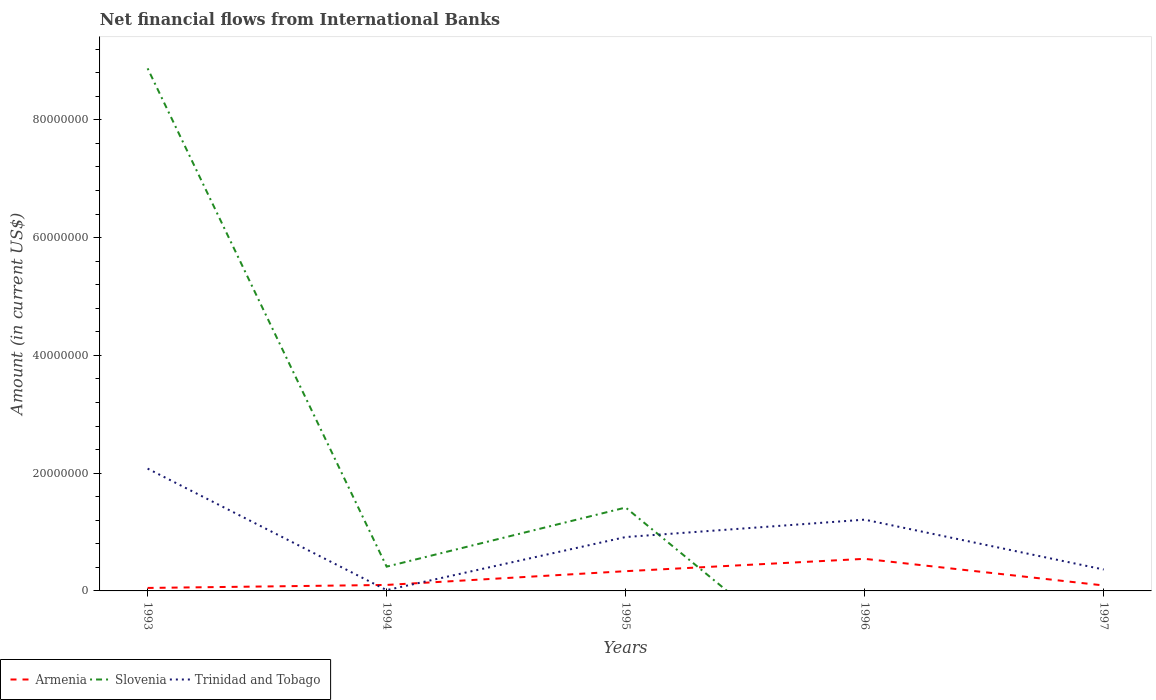Does the line corresponding to Armenia intersect with the line corresponding to Trinidad and Tobago?
Offer a very short reply. Yes. Across all years, what is the maximum net financial aid flows in Armenia?
Keep it short and to the point. 5.06e+05. What is the total net financial aid flows in Armenia in the graph?
Ensure brevity in your answer.  -5.11e+05. What is the difference between the highest and the second highest net financial aid flows in Slovenia?
Give a very brief answer. 8.87e+07. What is the difference between the highest and the lowest net financial aid flows in Slovenia?
Ensure brevity in your answer.  1. Is the net financial aid flows in Armenia strictly greater than the net financial aid flows in Trinidad and Tobago over the years?
Offer a terse response. No. How many lines are there?
Provide a short and direct response. 3. Are the values on the major ticks of Y-axis written in scientific E-notation?
Your answer should be compact. No. Does the graph contain any zero values?
Give a very brief answer. Yes. Where does the legend appear in the graph?
Offer a very short reply. Bottom left. How are the legend labels stacked?
Provide a short and direct response. Horizontal. What is the title of the graph?
Make the answer very short. Net financial flows from International Banks. Does "Comoros" appear as one of the legend labels in the graph?
Your response must be concise. No. What is the label or title of the Y-axis?
Ensure brevity in your answer.  Amount (in current US$). What is the Amount (in current US$) in Armenia in 1993?
Your answer should be very brief. 5.06e+05. What is the Amount (in current US$) in Slovenia in 1993?
Your answer should be compact. 8.87e+07. What is the Amount (in current US$) in Trinidad and Tobago in 1993?
Keep it short and to the point. 2.08e+07. What is the Amount (in current US$) in Armenia in 1994?
Make the answer very short. 1.02e+06. What is the Amount (in current US$) in Slovenia in 1994?
Your answer should be very brief. 4.12e+06. What is the Amount (in current US$) of Trinidad and Tobago in 1994?
Offer a terse response. 1.35e+05. What is the Amount (in current US$) of Armenia in 1995?
Provide a succinct answer. 3.35e+06. What is the Amount (in current US$) in Slovenia in 1995?
Offer a terse response. 1.42e+07. What is the Amount (in current US$) in Trinidad and Tobago in 1995?
Offer a terse response. 9.15e+06. What is the Amount (in current US$) in Armenia in 1996?
Ensure brevity in your answer.  5.45e+06. What is the Amount (in current US$) of Trinidad and Tobago in 1996?
Keep it short and to the point. 1.21e+07. What is the Amount (in current US$) of Armenia in 1997?
Provide a succinct answer. 9.28e+05. What is the Amount (in current US$) of Trinidad and Tobago in 1997?
Your answer should be compact. 3.64e+06. Across all years, what is the maximum Amount (in current US$) of Armenia?
Offer a terse response. 5.45e+06. Across all years, what is the maximum Amount (in current US$) of Slovenia?
Keep it short and to the point. 8.87e+07. Across all years, what is the maximum Amount (in current US$) of Trinidad and Tobago?
Offer a terse response. 2.08e+07. Across all years, what is the minimum Amount (in current US$) in Armenia?
Provide a succinct answer. 5.06e+05. Across all years, what is the minimum Amount (in current US$) in Trinidad and Tobago?
Offer a terse response. 1.35e+05. What is the total Amount (in current US$) of Armenia in the graph?
Your response must be concise. 1.12e+07. What is the total Amount (in current US$) of Slovenia in the graph?
Provide a short and direct response. 1.07e+08. What is the total Amount (in current US$) in Trinidad and Tobago in the graph?
Provide a succinct answer. 4.58e+07. What is the difference between the Amount (in current US$) of Armenia in 1993 and that in 1994?
Your answer should be very brief. -5.11e+05. What is the difference between the Amount (in current US$) of Slovenia in 1993 and that in 1994?
Make the answer very short. 8.46e+07. What is the difference between the Amount (in current US$) of Trinidad and Tobago in 1993 and that in 1994?
Offer a very short reply. 2.06e+07. What is the difference between the Amount (in current US$) in Armenia in 1993 and that in 1995?
Your response must be concise. -2.84e+06. What is the difference between the Amount (in current US$) of Slovenia in 1993 and that in 1995?
Make the answer very short. 7.46e+07. What is the difference between the Amount (in current US$) of Trinidad and Tobago in 1993 and that in 1995?
Offer a terse response. 1.16e+07. What is the difference between the Amount (in current US$) of Armenia in 1993 and that in 1996?
Offer a very short reply. -4.94e+06. What is the difference between the Amount (in current US$) of Trinidad and Tobago in 1993 and that in 1996?
Offer a very short reply. 8.67e+06. What is the difference between the Amount (in current US$) of Armenia in 1993 and that in 1997?
Keep it short and to the point. -4.22e+05. What is the difference between the Amount (in current US$) of Trinidad and Tobago in 1993 and that in 1997?
Your answer should be compact. 1.71e+07. What is the difference between the Amount (in current US$) in Armenia in 1994 and that in 1995?
Provide a succinct answer. -2.33e+06. What is the difference between the Amount (in current US$) of Slovenia in 1994 and that in 1995?
Offer a terse response. -1.00e+07. What is the difference between the Amount (in current US$) of Trinidad and Tobago in 1994 and that in 1995?
Give a very brief answer. -9.02e+06. What is the difference between the Amount (in current US$) of Armenia in 1994 and that in 1996?
Provide a succinct answer. -4.43e+06. What is the difference between the Amount (in current US$) of Trinidad and Tobago in 1994 and that in 1996?
Your answer should be very brief. -1.20e+07. What is the difference between the Amount (in current US$) of Armenia in 1994 and that in 1997?
Ensure brevity in your answer.  8.90e+04. What is the difference between the Amount (in current US$) of Trinidad and Tobago in 1994 and that in 1997?
Make the answer very short. -3.50e+06. What is the difference between the Amount (in current US$) in Armenia in 1995 and that in 1996?
Your response must be concise. -2.10e+06. What is the difference between the Amount (in current US$) in Trinidad and Tobago in 1995 and that in 1996?
Keep it short and to the point. -2.95e+06. What is the difference between the Amount (in current US$) of Armenia in 1995 and that in 1997?
Your response must be concise. 2.42e+06. What is the difference between the Amount (in current US$) in Trinidad and Tobago in 1995 and that in 1997?
Your answer should be compact. 5.51e+06. What is the difference between the Amount (in current US$) in Armenia in 1996 and that in 1997?
Your response must be concise. 4.52e+06. What is the difference between the Amount (in current US$) of Trinidad and Tobago in 1996 and that in 1997?
Keep it short and to the point. 8.46e+06. What is the difference between the Amount (in current US$) of Armenia in 1993 and the Amount (in current US$) of Slovenia in 1994?
Offer a very short reply. -3.62e+06. What is the difference between the Amount (in current US$) in Armenia in 1993 and the Amount (in current US$) in Trinidad and Tobago in 1994?
Ensure brevity in your answer.  3.71e+05. What is the difference between the Amount (in current US$) in Slovenia in 1993 and the Amount (in current US$) in Trinidad and Tobago in 1994?
Your answer should be compact. 8.86e+07. What is the difference between the Amount (in current US$) of Armenia in 1993 and the Amount (in current US$) of Slovenia in 1995?
Give a very brief answer. -1.37e+07. What is the difference between the Amount (in current US$) in Armenia in 1993 and the Amount (in current US$) in Trinidad and Tobago in 1995?
Your answer should be very brief. -8.64e+06. What is the difference between the Amount (in current US$) of Slovenia in 1993 and the Amount (in current US$) of Trinidad and Tobago in 1995?
Ensure brevity in your answer.  7.96e+07. What is the difference between the Amount (in current US$) of Armenia in 1993 and the Amount (in current US$) of Trinidad and Tobago in 1996?
Your answer should be very brief. -1.16e+07. What is the difference between the Amount (in current US$) of Slovenia in 1993 and the Amount (in current US$) of Trinidad and Tobago in 1996?
Make the answer very short. 7.66e+07. What is the difference between the Amount (in current US$) in Armenia in 1993 and the Amount (in current US$) in Trinidad and Tobago in 1997?
Your answer should be very brief. -3.13e+06. What is the difference between the Amount (in current US$) in Slovenia in 1993 and the Amount (in current US$) in Trinidad and Tobago in 1997?
Provide a succinct answer. 8.51e+07. What is the difference between the Amount (in current US$) of Armenia in 1994 and the Amount (in current US$) of Slovenia in 1995?
Your answer should be very brief. -1.31e+07. What is the difference between the Amount (in current US$) of Armenia in 1994 and the Amount (in current US$) of Trinidad and Tobago in 1995?
Provide a succinct answer. -8.13e+06. What is the difference between the Amount (in current US$) in Slovenia in 1994 and the Amount (in current US$) in Trinidad and Tobago in 1995?
Make the answer very short. -5.03e+06. What is the difference between the Amount (in current US$) of Armenia in 1994 and the Amount (in current US$) of Trinidad and Tobago in 1996?
Your response must be concise. -1.11e+07. What is the difference between the Amount (in current US$) in Slovenia in 1994 and the Amount (in current US$) in Trinidad and Tobago in 1996?
Your response must be concise. -7.98e+06. What is the difference between the Amount (in current US$) of Armenia in 1994 and the Amount (in current US$) of Trinidad and Tobago in 1997?
Provide a short and direct response. -2.62e+06. What is the difference between the Amount (in current US$) in Slovenia in 1994 and the Amount (in current US$) in Trinidad and Tobago in 1997?
Your answer should be very brief. 4.87e+05. What is the difference between the Amount (in current US$) of Armenia in 1995 and the Amount (in current US$) of Trinidad and Tobago in 1996?
Give a very brief answer. -8.75e+06. What is the difference between the Amount (in current US$) of Slovenia in 1995 and the Amount (in current US$) of Trinidad and Tobago in 1996?
Provide a short and direct response. 2.06e+06. What is the difference between the Amount (in current US$) of Armenia in 1995 and the Amount (in current US$) of Trinidad and Tobago in 1997?
Offer a very short reply. -2.86e+05. What is the difference between the Amount (in current US$) of Slovenia in 1995 and the Amount (in current US$) of Trinidad and Tobago in 1997?
Make the answer very short. 1.05e+07. What is the difference between the Amount (in current US$) of Armenia in 1996 and the Amount (in current US$) of Trinidad and Tobago in 1997?
Give a very brief answer. 1.81e+06. What is the average Amount (in current US$) in Armenia per year?
Ensure brevity in your answer.  2.25e+06. What is the average Amount (in current US$) in Slovenia per year?
Offer a terse response. 2.14e+07. What is the average Amount (in current US$) in Trinidad and Tobago per year?
Ensure brevity in your answer.  9.16e+06. In the year 1993, what is the difference between the Amount (in current US$) of Armenia and Amount (in current US$) of Slovenia?
Provide a short and direct response. -8.82e+07. In the year 1993, what is the difference between the Amount (in current US$) of Armenia and Amount (in current US$) of Trinidad and Tobago?
Provide a short and direct response. -2.03e+07. In the year 1993, what is the difference between the Amount (in current US$) in Slovenia and Amount (in current US$) in Trinidad and Tobago?
Your response must be concise. 6.80e+07. In the year 1994, what is the difference between the Amount (in current US$) in Armenia and Amount (in current US$) in Slovenia?
Your answer should be compact. -3.11e+06. In the year 1994, what is the difference between the Amount (in current US$) of Armenia and Amount (in current US$) of Trinidad and Tobago?
Your answer should be very brief. 8.82e+05. In the year 1994, what is the difference between the Amount (in current US$) of Slovenia and Amount (in current US$) of Trinidad and Tobago?
Ensure brevity in your answer.  3.99e+06. In the year 1995, what is the difference between the Amount (in current US$) in Armenia and Amount (in current US$) in Slovenia?
Provide a short and direct response. -1.08e+07. In the year 1995, what is the difference between the Amount (in current US$) in Armenia and Amount (in current US$) in Trinidad and Tobago?
Your answer should be very brief. -5.80e+06. In the year 1995, what is the difference between the Amount (in current US$) in Slovenia and Amount (in current US$) in Trinidad and Tobago?
Provide a short and direct response. 5.01e+06. In the year 1996, what is the difference between the Amount (in current US$) of Armenia and Amount (in current US$) of Trinidad and Tobago?
Your answer should be very brief. -6.65e+06. In the year 1997, what is the difference between the Amount (in current US$) in Armenia and Amount (in current US$) in Trinidad and Tobago?
Give a very brief answer. -2.71e+06. What is the ratio of the Amount (in current US$) of Armenia in 1993 to that in 1994?
Provide a succinct answer. 0.5. What is the ratio of the Amount (in current US$) in Slovenia in 1993 to that in 1994?
Give a very brief answer. 21.52. What is the ratio of the Amount (in current US$) in Trinidad and Tobago in 1993 to that in 1994?
Make the answer very short. 153.62. What is the ratio of the Amount (in current US$) of Armenia in 1993 to that in 1995?
Provide a short and direct response. 0.15. What is the ratio of the Amount (in current US$) of Slovenia in 1993 to that in 1995?
Your response must be concise. 6.27. What is the ratio of the Amount (in current US$) of Trinidad and Tobago in 1993 to that in 1995?
Offer a very short reply. 2.27. What is the ratio of the Amount (in current US$) of Armenia in 1993 to that in 1996?
Your response must be concise. 0.09. What is the ratio of the Amount (in current US$) of Trinidad and Tobago in 1993 to that in 1996?
Offer a terse response. 1.72. What is the ratio of the Amount (in current US$) of Armenia in 1993 to that in 1997?
Your answer should be compact. 0.55. What is the ratio of the Amount (in current US$) in Trinidad and Tobago in 1993 to that in 1997?
Give a very brief answer. 5.71. What is the ratio of the Amount (in current US$) of Armenia in 1994 to that in 1995?
Offer a very short reply. 0.3. What is the ratio of the Amount (in current US$) in Slovenia in 1994 to that in 1995?
Your answer should be compact. 0.29. What is the ratio of the Amount (in current US$) of Trinidad and Tobago in 1994 to that in 1995?
Ensure brevity in your answer.  0.01. What is the ratio of the Amount (in current US$) in Armenia in 1994 to that in 1996?
Make the answer very short. 0.19. What is the ratio of the Amount (in current US$) in Trinidad and Tobago in 1994 to that in 1996?
Give a very brief answer. 0.01. What is the ratio of the Amount (in current US$) of Armenia in 1994 to that in 1997?
Offer a very short reply. 1.1. What is the ratio of the Amount (in current US$) of Trinidad and Tobago in 1994 to that in 1997?
Provide a short and direct response. 0.04. What is the ratio of the Amount (in current US$) in Armenia in 1995 to that in 1996?
Offer a terse response. 0.62. What is the ratio of the Amount (in current US$) of Trinidad and Tobago in 1995 to that in 1996?
Your response must be concise. 0.76. What is the ratio of the Amount (in current US$) of Armenia in 1995 to that in 1997?
Keep it short and to the point. 3.61. What is the ratio of the Amount (in current US$) of Trinidad and Tobago in 1995 to that in 1997?
Your answer should be compact. 2.52. What is the ratio of the Amount (in current US$) of Armenia in 1996 to that in 1997?
Make the answer very short. 5.87. What is the ratio of the Amount (in current US$) in Trinidad and Tobago in 1996 to that in 1997?
Give a very brief answer. 3.33. What is the difference between the highest and the second highest Amount (in current US$) in Armenia?
Give a very brief answer. 2.10e+06. What is the difference between the highest and the second highest Amount (in current US$) of Slovenia?
Give a very brief answer. 7.46e+07. What is the difference between the highest and the second highest Amount (in current US$) of Trinidad and Tobago?
Offer a very short reply. 8.67e+06. What is the difference between the highest and the lowest Amount (in current US$) of Armenia?
Your response must be concise. 4.94e+06. What is the difference between the highest and the lowest Amount (in current US$) in Slovenia?
Provide a short and direct response. 8.87e+07. What is the difference between the highest and the lowest Amount (in current US$) in Trinidad and Tobago?
Your answer should be compact. 2.06e+07. 